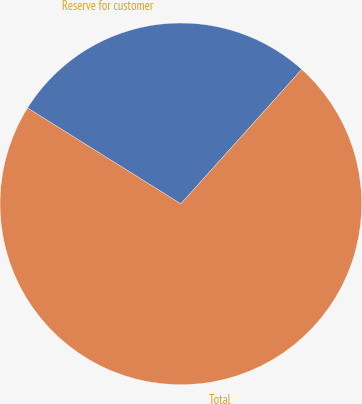Convert chart. <chart><loc_0><loc_0><loc_500><loc_500><pie_chart><fcel>Reserve for customer<fcel>Total<nl><fcel>27.76%<fcel>72.24%<nl></chart> 